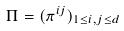Convert formula to latex. <formula><loc_0><loc_0><loc_500><loc_500>\Pi = ( \pi ^ { i j } ) _ { 1 \leq i , j \leq d }</formula> 